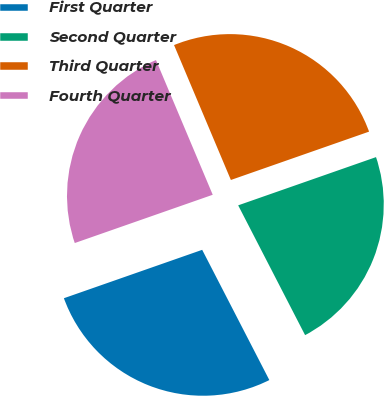Convert chart. <chart><loc_0><loc_0><loc_500><loc_500><pie_chart><fcel>First Quarter<fcel>Second Quarter<fcel>Third Quarter<fcel>Fourth Quarter<nl><fcel>27.22%<fcel>22.78%<fcel>25.99%<fcel>24.01%<nl></chart> 